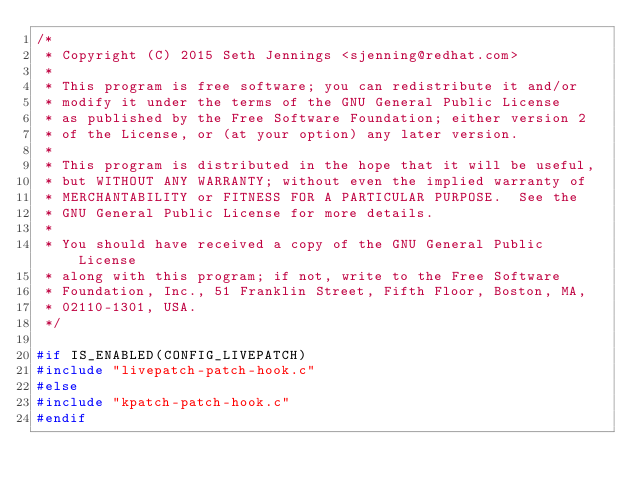Convert code to text. <code><loc_0><loc_0><loc_500><loc_500><_C_>/*
 * Copyright (C) 2015 Seth Jennings <sjenning@redhat.com>
 *
 * This program is free software; you can redistribute it and/or
 * modify it under the terms of the GNU General Public License
 * as published by the Free Software Foundation; either version 2
 * of the License, or (at your option) any later version.
 *
 * This program is distributed in the hope that it will be useful,
 * but WITHOUT ANY WARRANTY; without even the implied warranty of
 * MERCHANTABILITY or FITNESS FOR A PARTICULAR PURPOSE.  See the
 * GNU General Public License for more details.
 *
 * You should have received a copy of the GNU General Public License
 * along with this program; if not, write to the Free Software
 * Foundation, Inc., 51 Franklin Street, Fifth Floor, Boston, MA,
 * 02110-1301, USA.
 */

#if IS_ENABLED(CONFIG_LIVEPATCH)
#include "livepatch-patch-hook.c"
#else
#include "kpatch-patch-hook.c"
#endif

</code> 